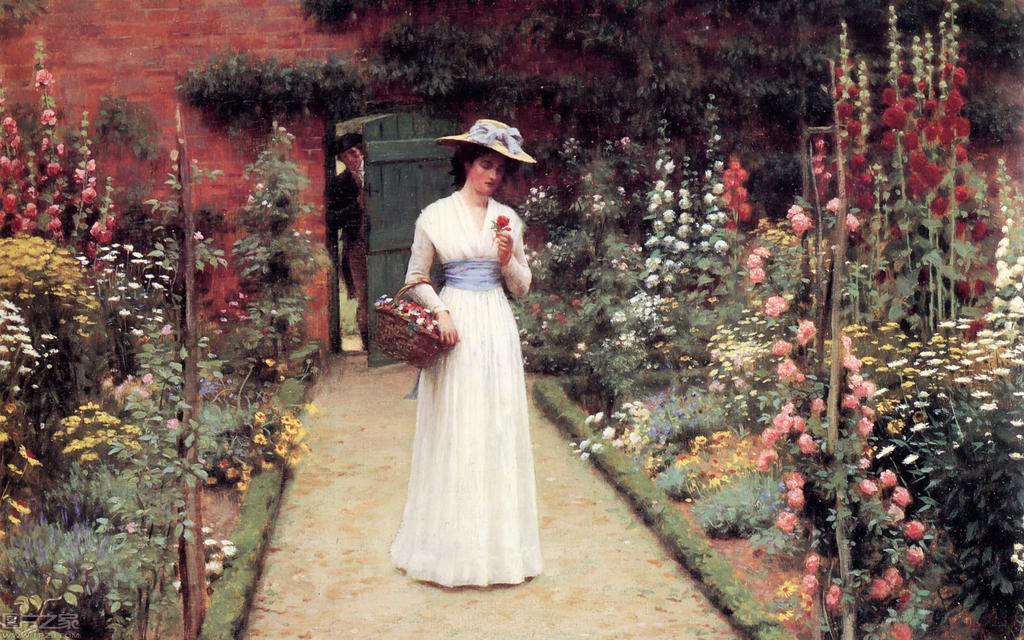Describe this image in one or two sentences. In this image i can see a painting of a woman and a man. The woman is holding flowers and basket. The woman is wearing a white color dress and hat. In the background I can see a wall, door and plants. 